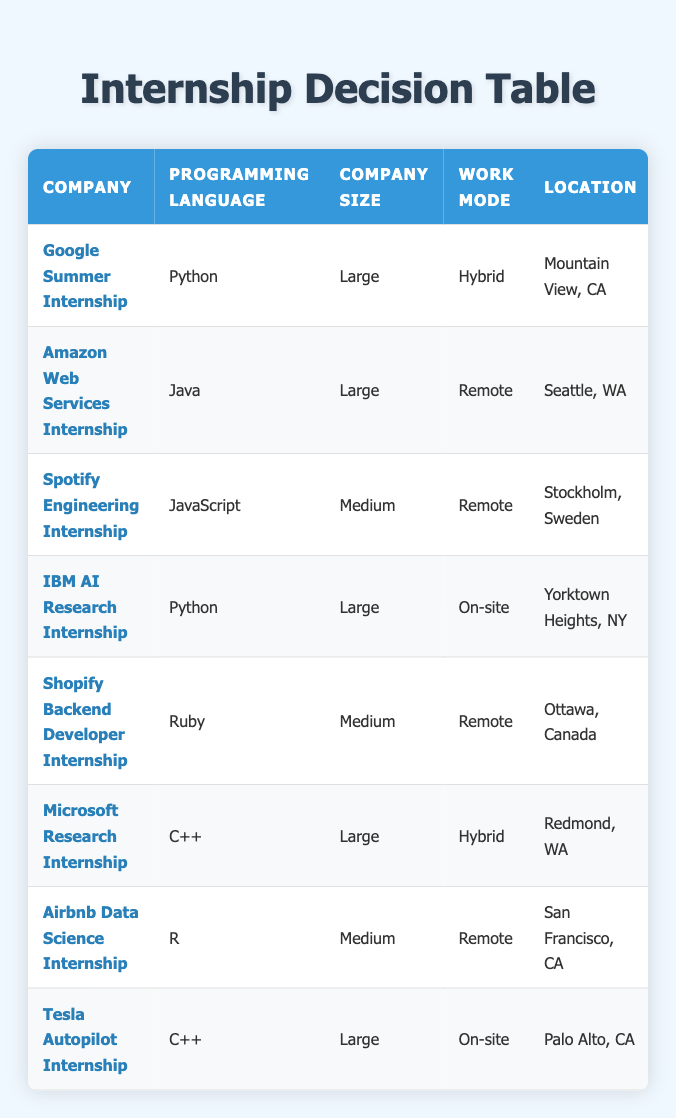What programming language is used in the Google Summer Internship? The table lists the "Programming Language" for each internship opportunity, and for the Google Summer Internship, it specifies "Python" in that column.
Answer: Python Which internship has the longest duration? The durations listed in the table show that both the IBM AI Research Internship and the Tesla Autopilot Internship have durations of "6 months," which is the longest among all listed internships.
Answer: IBM AI Research Internship, Tesla Autopilot Internship Is the Amazon Web Services Internship remote? Referring to the table, the "Work Mode" column indicates that the Amazon Web Services Internship is "Remote." Thus, the answer is yes.
Answer: Yes How many internships are available in the "Tech" industry? Looking at the table, the internships listed under the "Tech" industry are the Google Summer Internship and the Microsoft Research Internship. Hence, there are two internships in that industry.
Answer: 2 Compare the company sizes of internships that have a duration of 4 months. In the table, there are two internships with a duration of 4 months: Amazon Web Services Internship (Large) and Shopify Backend Developer Internship (Medium). This shows the difference in company size for these two internships.
Answer: Large, Medium What is the location of the Spotify Engineering Internship? The "Location" column in the table specifies that the Spotify Engineering Internship is located in "Stockholm, Sweden." This can be directly retrieved.
Answer: Stockholm, Sweden Which internships require on-site work? In the table, the internships that specify "On-site" as the work mode are the IBM AI Research Internship and the Tesla Autopilot Internship. This requires checking the "Work Mode" column to determine which internships are on-site.
Answer: IBM AI Research Internship, Tesla Autopilot Internship If you prefer to work remotely, how many internship options do you have? By checking the "Work Mode" column for "Remote," we find three internships: Amazon Web Services Internship, Spotify Engineering Internship, and Airbnb Data Science Internship. Thus, the total number of remote options is three.
Answer: 3 What is the industry of the Microsoft Research Internship? The "Industry" column in the table identifies that the Microsoft Research Internship is in the "Tech" industry. This information can be accessed directly from the table.
Answer: Tech 